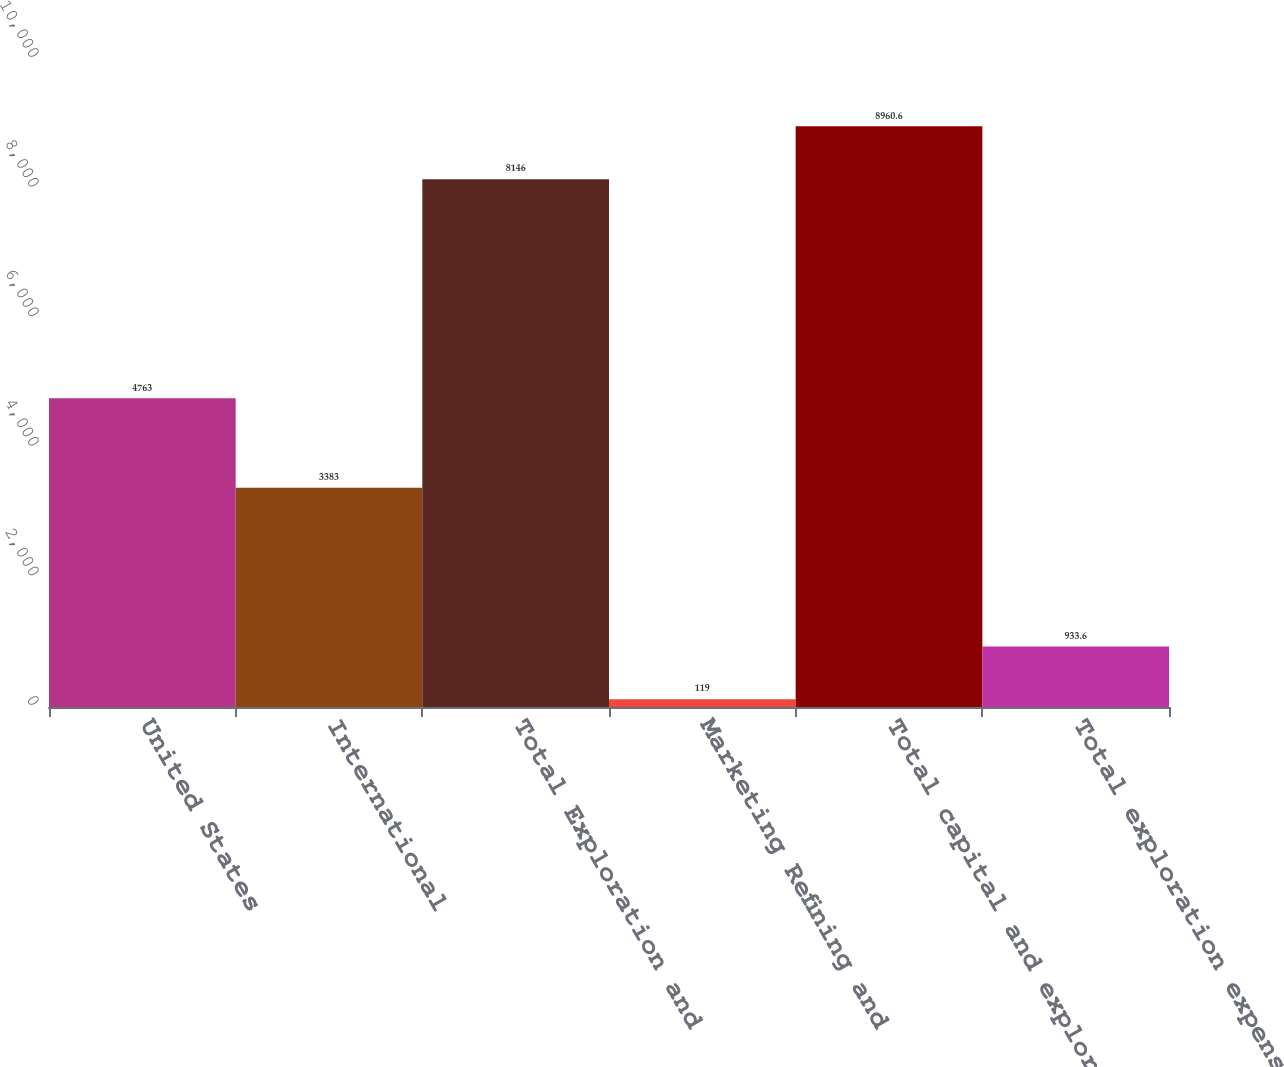<chart> <loc_0><loc_0><loc_500><loc_500><bar_chart><fcel>United States<fcel>International<fcel>Total Exploration and<fcel>Marketing Refining and<fcel>Total capital and exploratory<fcel>Total exploration expenses<nl><fcel>4763<fcel>3383<fcel>8146<fcel>119<fcel>8960.6<fcel>933.6<nl></chart> 